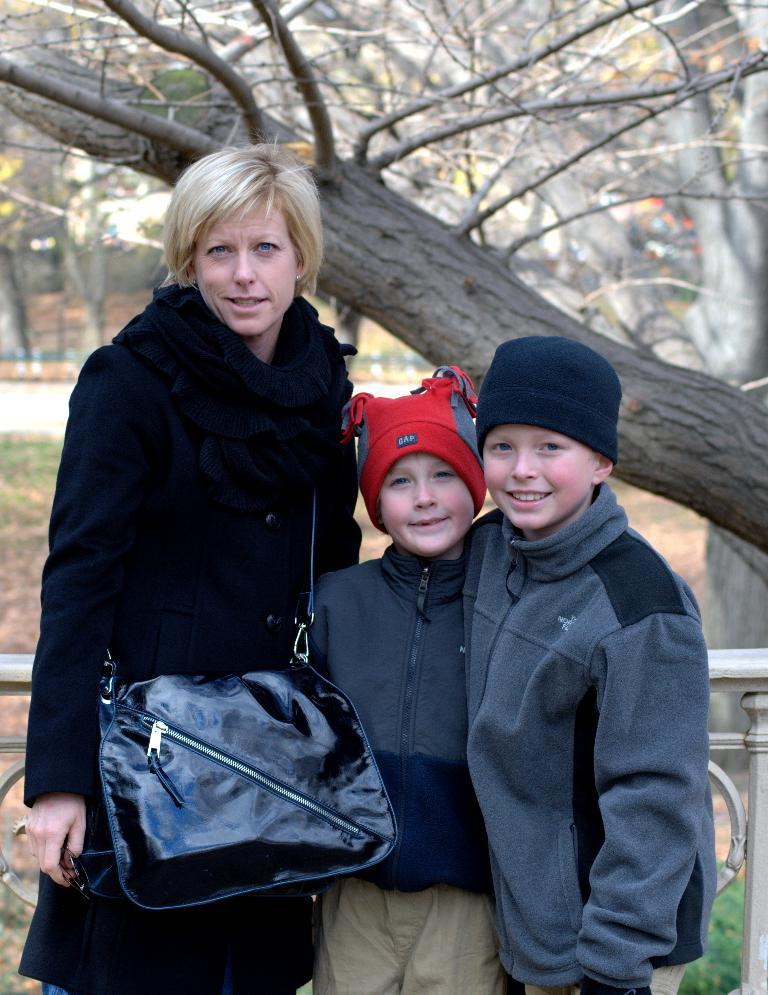How many kids are in the image? There are two kids in the image. Who else is present in the image besides the kids? There is a woman in the image. What is the woman wearing in the image? The woman is wearing a handbag. What can be seen in the background of the image? There is a tree and a road in the background of the image. What type of texture can be seen on the building in the image? There is no building present in the image, so it is not possible to determine the texture of any building. 